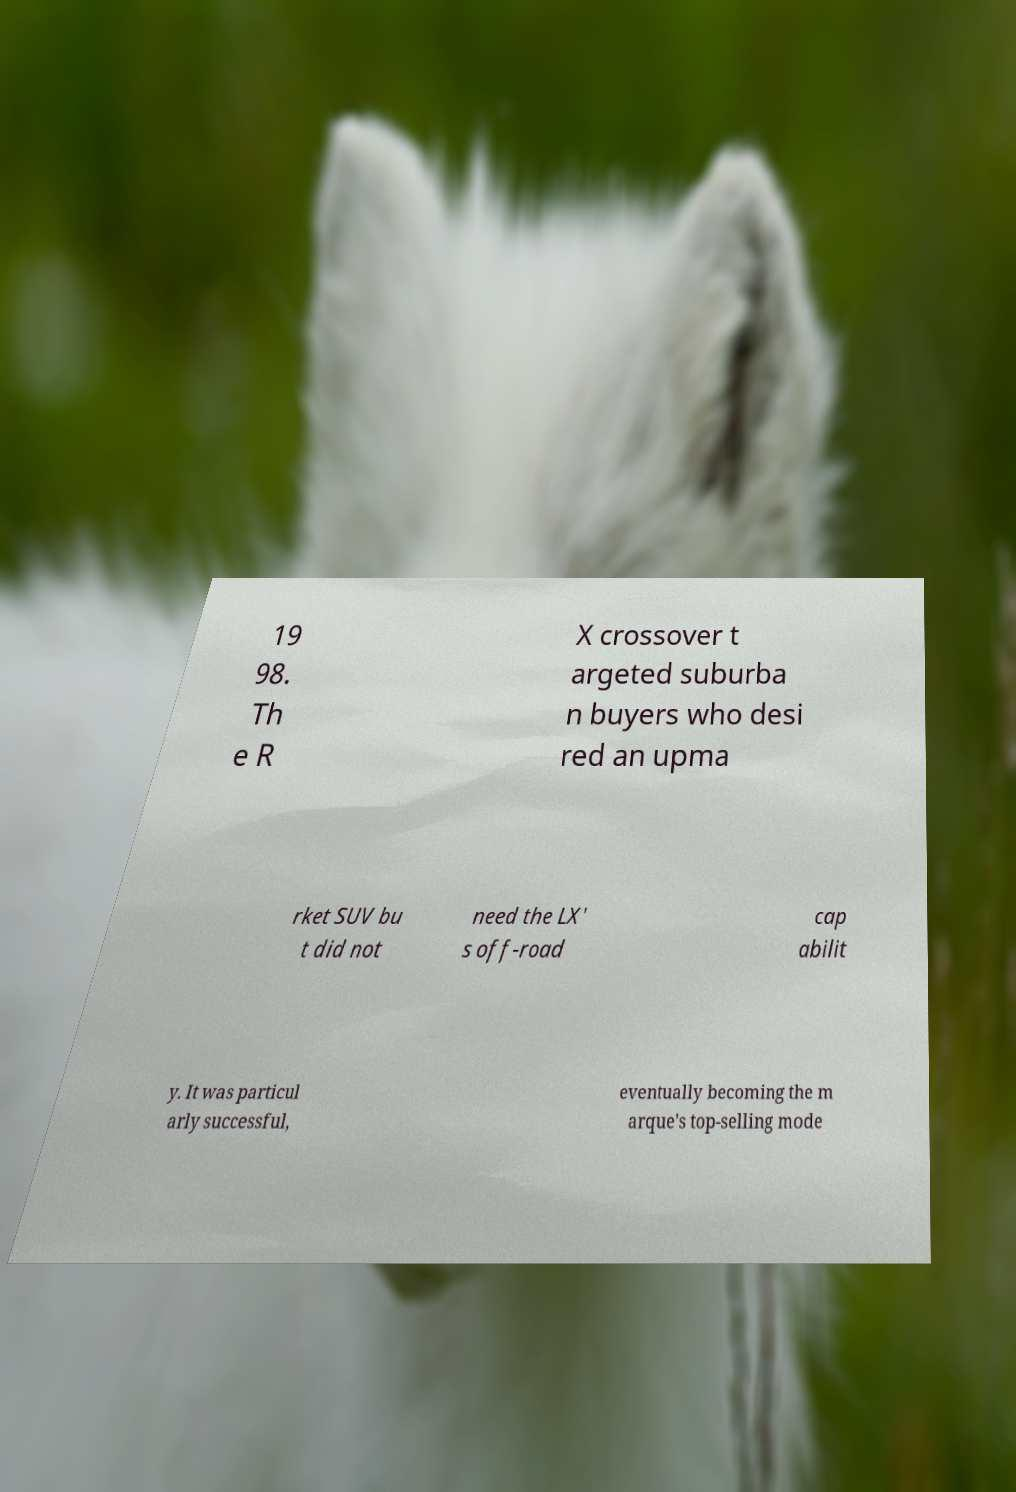Please read and relay the text visible in this image. What does it say? 19 98. Th e R X crossover t argeted suburba n buyers who desi red an upma rket SUV bu t did not need the LX' s off-road cap abilit y. It was particul arly successful, eventually becoming the m arque's top-selling mode 